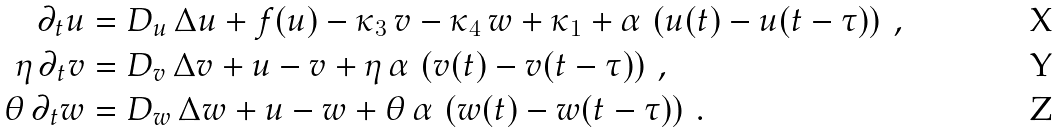<formula> <loc_0><loc_0><loc_500><loc_500>\partial _ { t } u & = D _ { u } \, \Delta u + f ( u ) - \kappa _ { 3 } \, v - \kappa _ { 4 } \, w + \kappa _ { 1 } + \alpha \, \left ( u ( t ) - u ( t - \tau ) \right ) \, , \\ \eta \, \partial _ { t } v & = D _ { v } \, \Delta v + u - v + \eta \, \alpha \, \left ( v ( t ) - v ( t - \tau ) \right ) \, , \\ \theta \, \partial _ { t } w & = D _ { w } \, \Delta w + u - w + \theta \, \alpha \, \left ( w ( t ) - w ( t - \tau ) \right ) \, .</formula> 